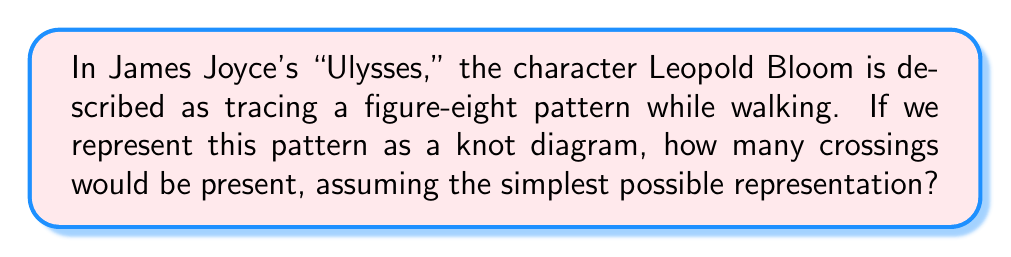Teach me how to tackle this problem. To approach this question from a literary perspective while incorporating knot theory:

1. Recognize that the figure-eight pattern in literature often symbolizes infinity or cyclical nature of life.

2. In knot theory, a figure-eight knot is one of the simplest non-trivial knots.

3. The standard diagram of a figure-eight knot consists of four crossings.

4. We can represent this mathematically using the crossing number:
   Let $c(K)$ be the crossing number of knot $K$.
   For a figure-eight knot $F$, we have:
   $$c(F) = 4$$

5. This minimal crossing number corresponds to the simplest possible representation, which aligns with the question's assumption.

6. The figure-eight knot can be visualized as:

[asy]
import geometry;

pair[] points = {(0,1), (1,0), (0,-1), (-1,0)};
path knot = interp(points,tension=0.8)--cycle;

draw(knot, linewidth(1));
draw(shift(0.1,0.1)*knot, linewidth(1));

dot((0,1));
dot((1,0));
dot((0,-1));
dot((-1,0));
[/asy]

7. In literature, this simple yet non-trivial structure could symbolize the complexity of Bloom's journey through Dublin, which appears cyclical but is full of intricate encounters and revelations.
Answer: 4 crossings 